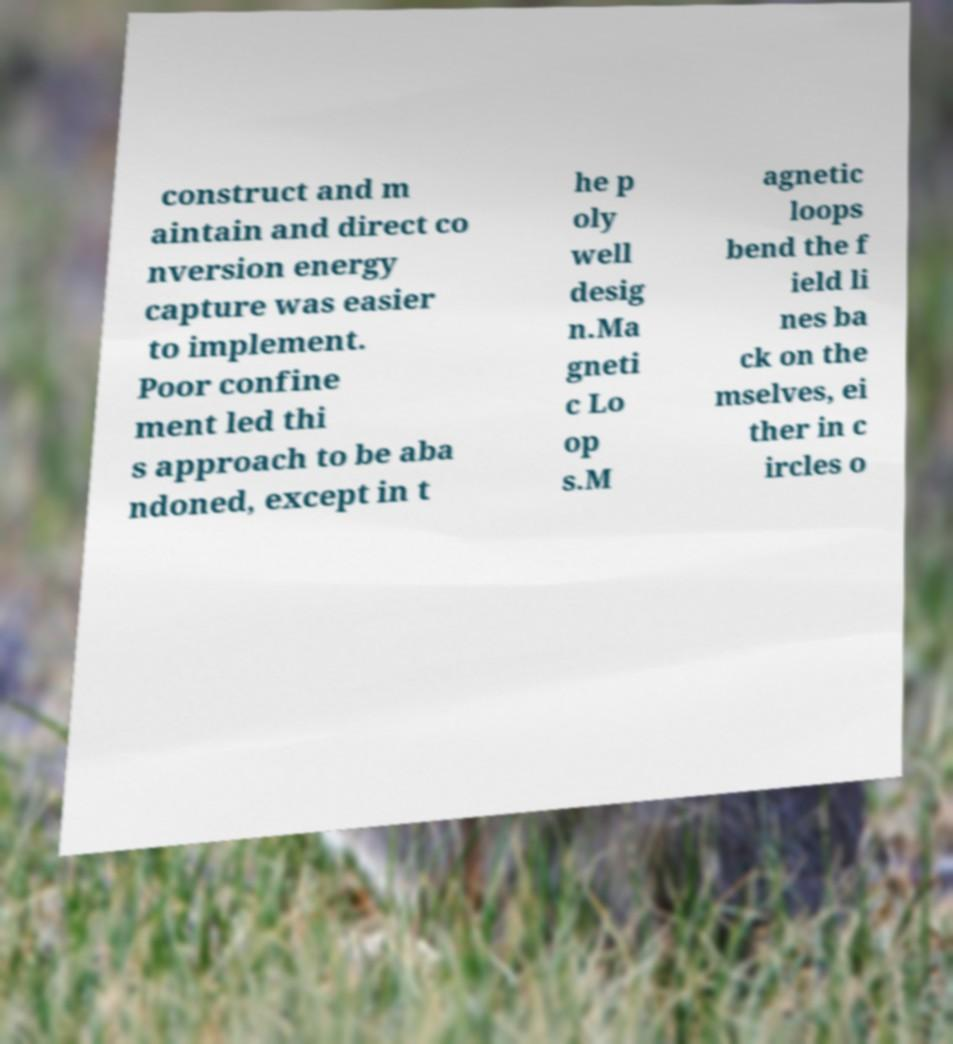Please read and relay the text visible in this image. What does it say? construct and m aintain and direct co nversion energy capture was easier to implement. Poor confine ment led thi s approach to be aba ndoned, except in t he p oly well desig n.Ma gneti c Lo op s.M agnetic loops bend the f ield li nes ba ck on the mselves, ei ther in c ircles o 